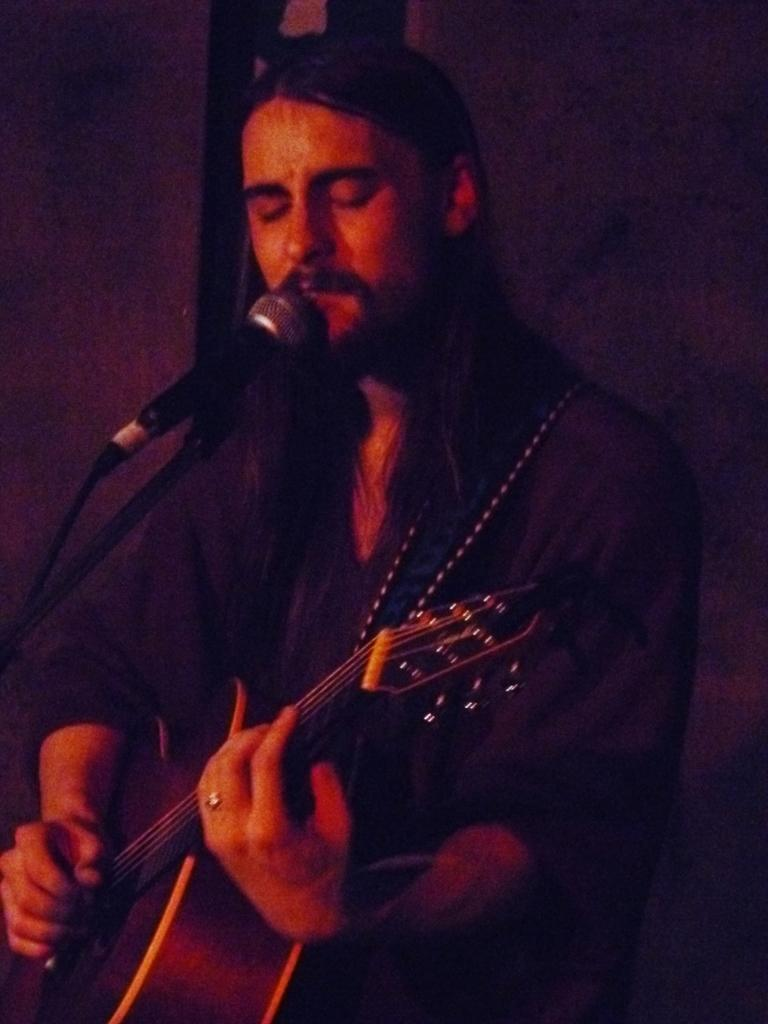What is the main subject of the image? There is a person in the image. What is the person doing in the image? The person is standing and holding a guitar in his hand. What object is in front of the person? A: There is a microphone with a stand in front of the person. How many geese are resting on the microphone stand in the image? There are no geese present in the image, and therefore no geese are resting on the microphone stand. 